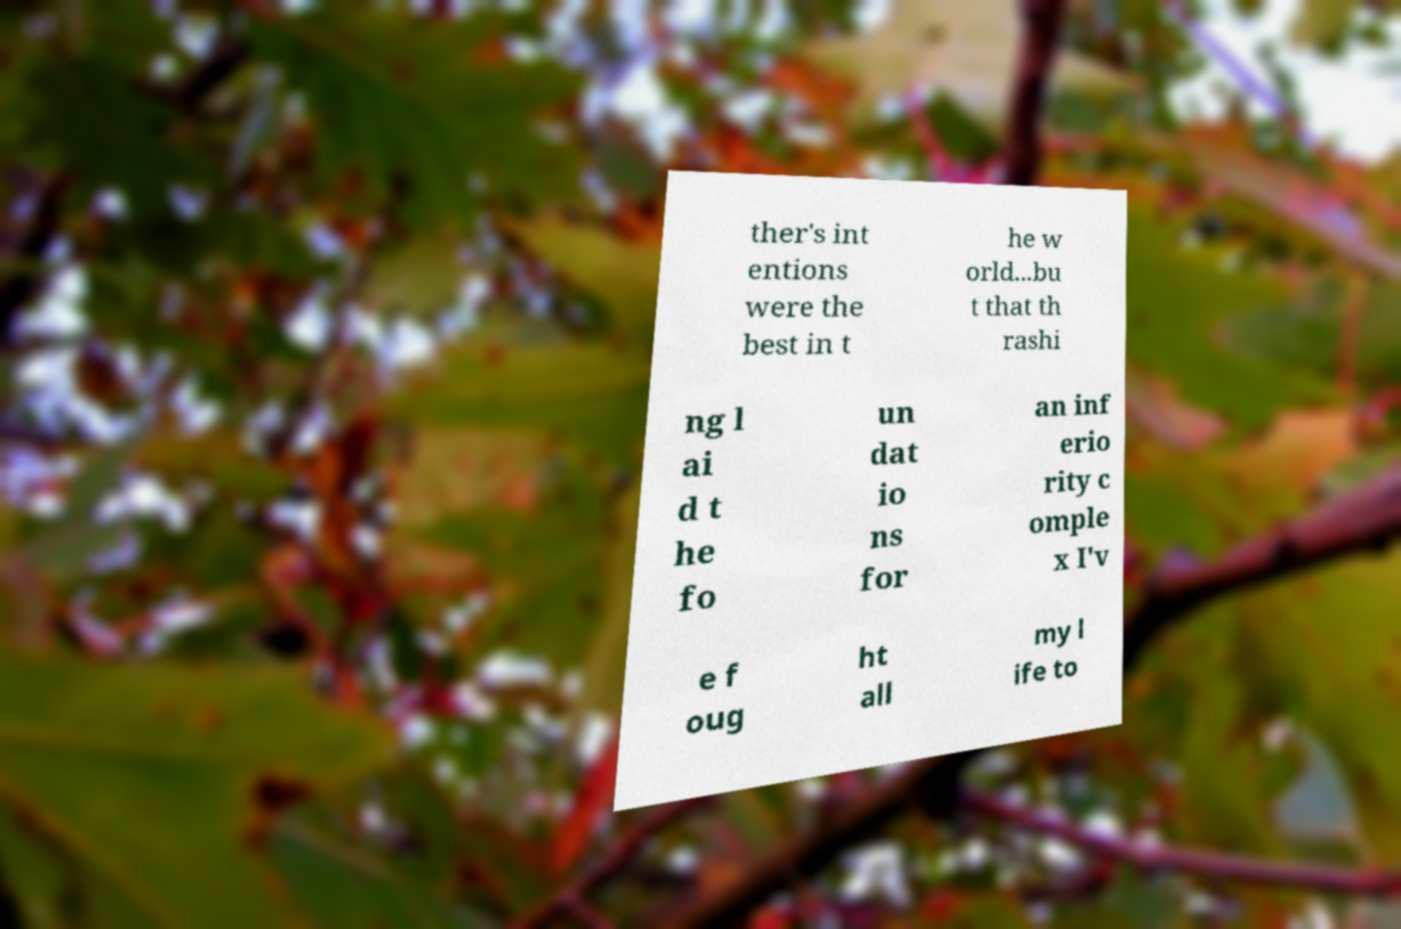Could you extract and type out the text from this image? ther's int entions were the best in t he w orld...bu t that th rashi ng l ai d t he fo un dat io ns for an inf erio rity c omple x I'v e f oug ht all my l ife to 